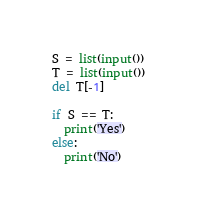Convert code to text. <code><loc_0><loc_0><loc_500><loc_500><_Python_>S = list(input())
T = list(input())
del T[-1]

if S == T:
  print('Yes')
else:
  print('No')
</code> 